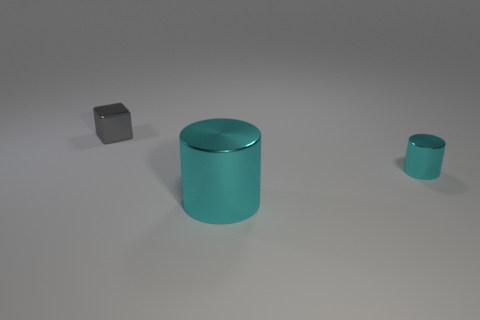Do the cyan object in front of the tiny cyan cylinder and the gray thing have the same shape?
Ensure brevity in your answer.  No. Are there fewer cyan metallic cylinders that are on the right side of the small cyan object than tiny things that are on the left side of the large cyan cylinder?
Your answer should be compact. Yes. What is the big object made of?
Give a very brief answer. Metal. There is a large metal cylinder; does it have the same color as the small metallic object that is in front of the tiny gray metallic object?
Offer a terse response. Yes. There is a tiny metallic block; what number of small objects are left of it?
Give a very brief answer. 0. Are there fewer small gray blocks behind the gray block than tiny metallic cubes?
Offer a terse response. Yes. What is the color of the block?
Give a very brief answer. Gray. Does the small metallic object in front of the small gray block have the same color as the big object?
Your answer should be very brief. Yes. There is another thing that is the same shape as the small cyan metal thing; what color is it?
Offer a very short reply. Cyan. How many small objects are gray spheres or metallic cylinders?
Provide a short and direct response. 1. 